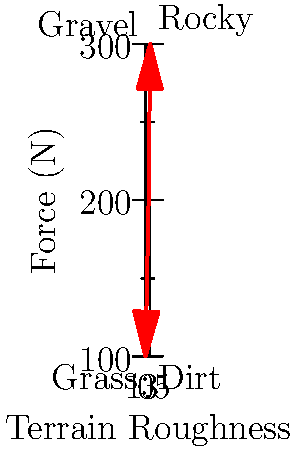As a retired hunt warden, you're assisting in a wildlife management operation. You need to move a 100 kg deer carcass across different terrains. The graph shows the force required to drag the carcass on various surfaces. If the coefficient of friction on gravel is 0.4, what is the approximate normal force exerted by the ground on the carcass? Let's approach this step-by-step:

1) From the graph, we can see that the force required to drag the carcass on gravel is approximately 200 N.

2) The force required to drag an object is equal to the friction force, which is given by:

   $F_f = \mu F_n$

   Where $F_f$ is the friction force, $\mu$ is the coefficient of friction, and $F_n$ is the normal force.

3) We're given that $\mu = 0.4$ for gravel, and we can see from the graph that $F_f \approx 200$ N.

4) Substituting these values into the equation:

   $200 = 0.4 F_n$

5) Solving for $F_n$:

   $F_n = \frac{200}{0.4} = 500$ N

6) We can verify this result: The normal force should be approximately equal to the weight of the carcass. 
   
   $W = mg = 100 \text{ kg} \times 9.8 \text{ m/s}^2 = 980 \text{ N}$

   Our calculated normal force (500 N) is about half of this, which makes sense as the carcass is being dragged, not lifted entirely.
Answer: 500 N 